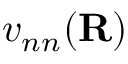<formula> <loc_0><loc_0><loc_500><loc_500>v _ { n n } ( { R } )</formula> 